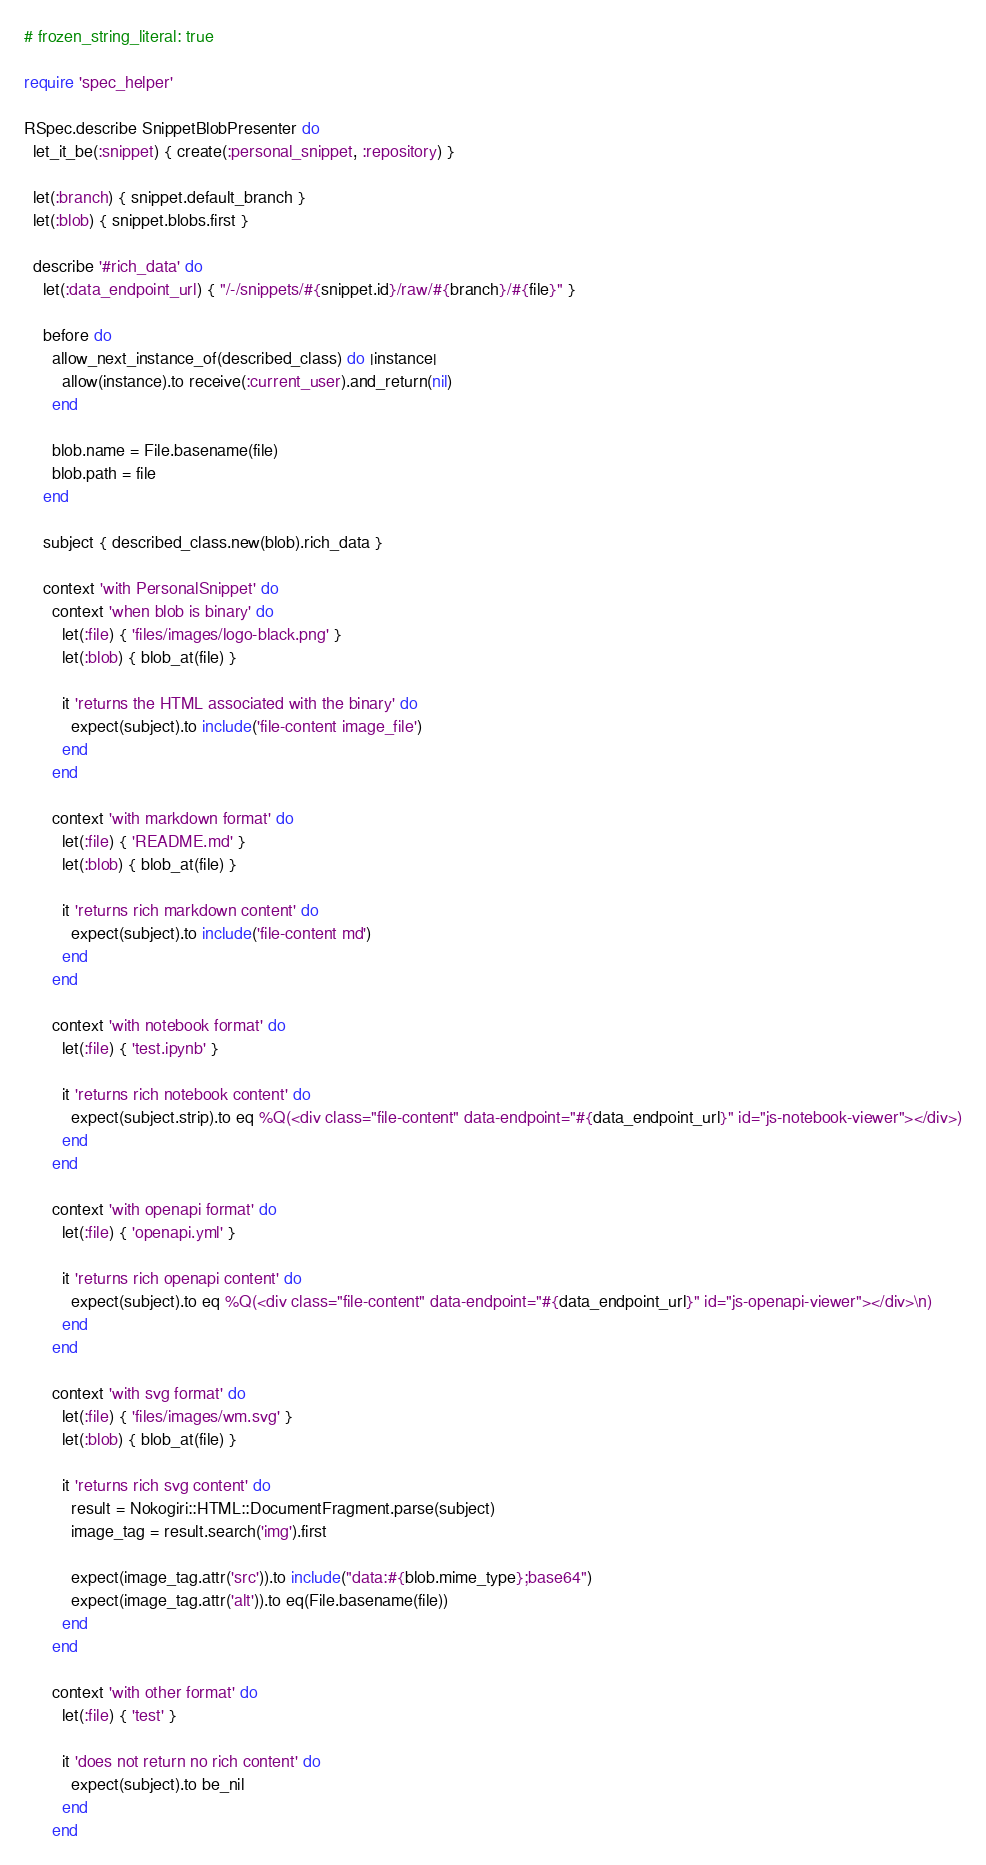Convert code to text. <code><loc_0><loc_0><loc_500><loc_500><_Ruby_># frozen_string_literal: true

require 'spec_helper'

RSpec.describe SnippetBlobPresenter do
  let_it_be(:snippet) { create(:personal_snippet, :repository) }

  let(:branch) { snippet.default_branch }
  let(:blob) { snippet.blobs.first }

  describe '#rich_data' do
    let(:data_endpoint_url) { "/-/snippets/#{snippet.id}/raw/#{branch}/#{file}" }

    before do
      allow_next_instance_of(described_class) do |instance|
        allow(instance).to receive(:current_user).and_return(nil)
      end

      blob.name = File.basename(file)
      blob.path = file
    end

    subject { described_class.new(blob).rich_data }

    context 'with PersonalSnippet' do
      context 'when blob is binary' do
        let(:file) { 'files/images/logo-black.png' }
        let(:blob) { blob_at(file) }

        it 'returns the HTML associated with the binary' do
          expect(subject).to include('file-content image_file')
        end
      end

      context 'with markdown format' do
        let(:file) { 'README.md' }
        let(:blob) { blob_at(file) }

        it 'returns rich markdown content' do
          expect(subject).to include('file-content md')
        end
      end

      context 'with notebook format' do
        let(:file) { 'test.ipynb' }

        it 'returns rich notebook content' do
          expect(subject.strip).to eq %Q(<div class="file-content" data-endpoint="#{data_endpoint_url}" id="js-notebook-viewer"></div>)
        end
      end

      context 'with openapi format' do
        let(:file) { 'openapi.yml' }

        it 'returns rich openapi content' do
          expect(subject).to eq %Q(<div class="file-content" data-endpoint="#{data_endpoint_url}" id="js-openapi-viewer"></div>\n)
        end
      end

      context 'with svg format' do
        let(:file) { 'files/images/wm.svg' }
        let(:blob) { blob_at(file) }

        it 'returns rich svg content' do
          result = Nokogiri::HTML::DocumentFragment.parse(subject)
          image_tag = result.search('img').first

          expect(image_tag.attr('src')).to include("data:#{blob.mime_type};base64")
          expect(image_tag.attr('alt')).to eq(File.basename(file))
        end
      end

      context 'with other format' do
        let(:file) { 'test' }

        it 'does not return no rich content' do
          expect(subject).to be_nil
        end
      end</code> 